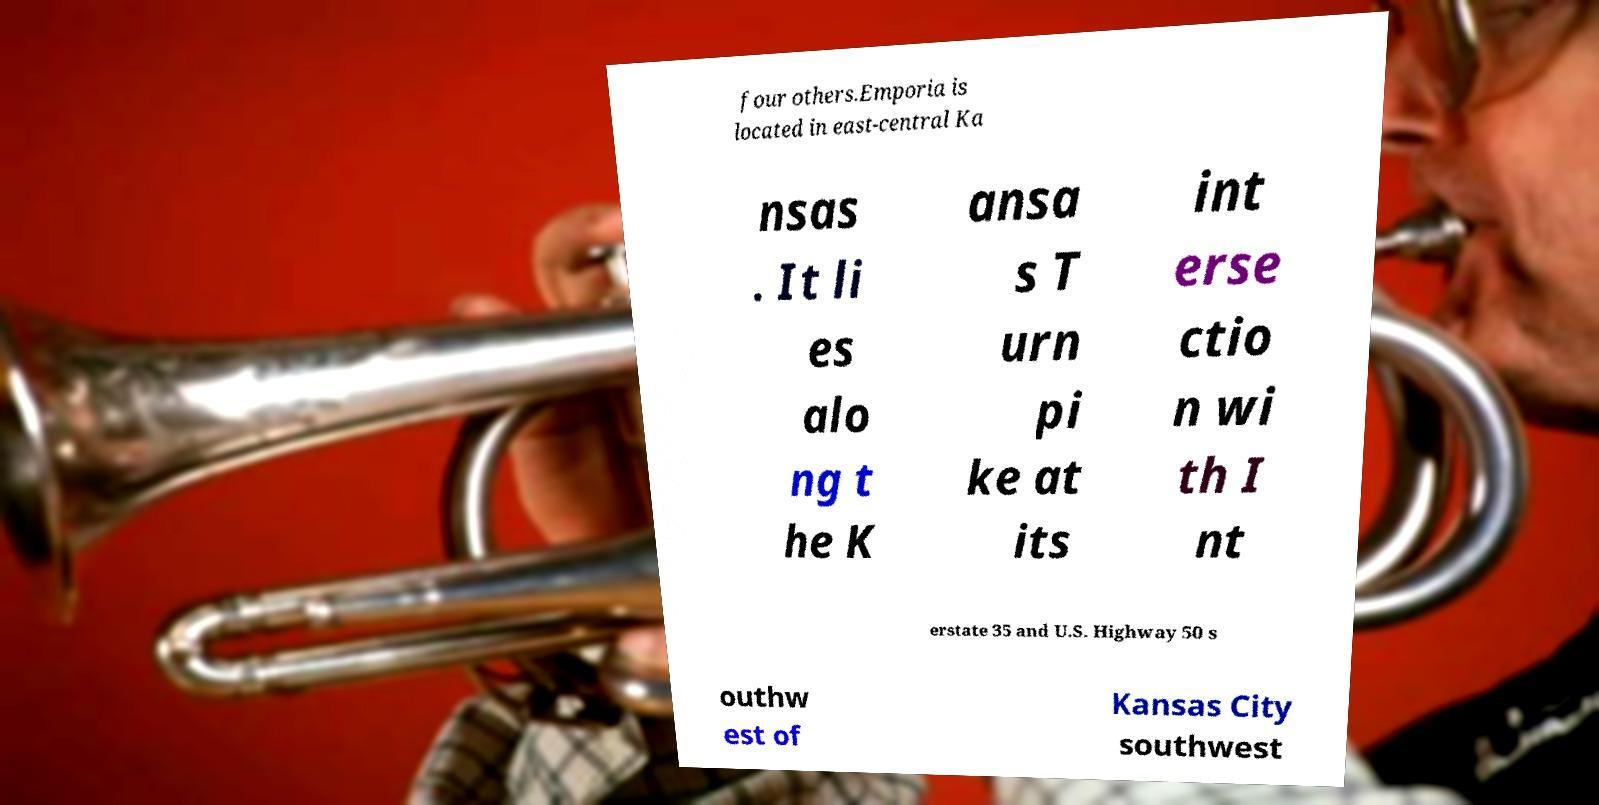Could you extract and type out the text from this image? four others.Emporia is located in east-central Ka nsas . It li es alo ng t he K ansa s T urn pi ke at its int erse ctio n wi th I nt erstate 35 and U.S. Highway 50 s outhw est of Kansas City southwest 